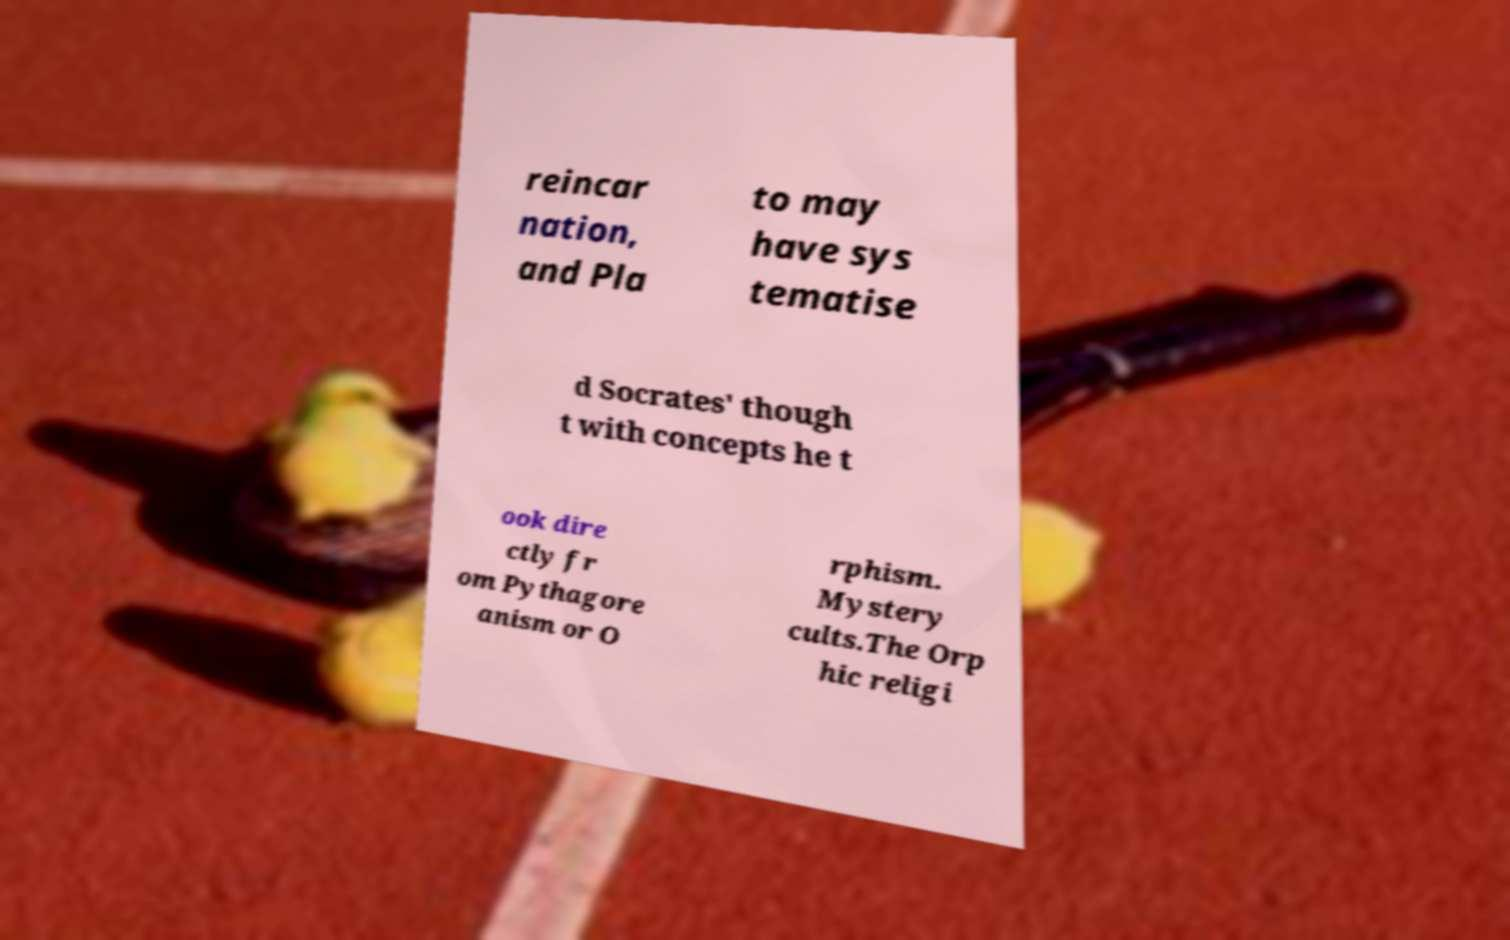Please read and relay the text visible in this image. What does it say? reincar nation, and Pla to may have sys tematise d Socrates' though t with concepts he t ook dire ctly fr om Pythagore anism or O rphism. Mystery cults.The Orp hic religi 